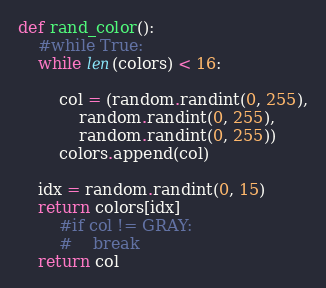<code> <loc_0><loc_0><loc_500><loc_500><_Python_>
def rand_color():
    #while True:
    while len(colors) < 16:

        col = (random.randint(0, 255),
            random.randint(0, 255),
            random.randint(0, 255))
        colors.append(col)

    idx = random.randint(0, 15)
    return colors[idx]
        #if col != GRAY:
        #    break
    return col
</code> 